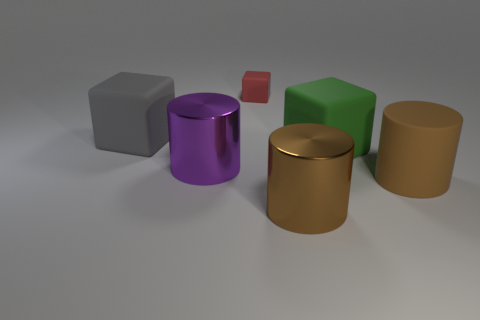Add 4 large shiny things. How many objects exist? 10 Add 3 purple cylinders. How many purple cylinders are left? 4 Add 1 tiny blue balls. How many tiny blue balls exist? 1 Subtract 0 brown blocks. How many objects are left? 6 Subtract all small red matte cubes. Subtract all small red rubber objects. How many objects are left? 4 